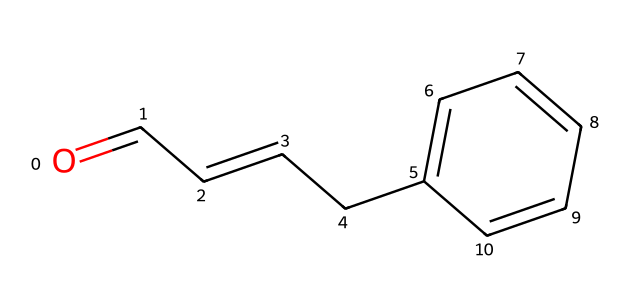What is the carbon count in cinnamaldehyde? By examining the SMILES representation, we identify that there are 9 carbon atoms in the structure; each "C" represents a carbon atom, and we count a total of 9, including those in the aromatic ring and the chain.
Answer: 9 How many hydrogen atoms are bonded to the carbon atoms? In the SMILES representation, every carbon typically bonds with enough hydrogen atoms to satisfy a total of four bonds. Counting the explicitly shown hydrogens in the chemical structure, there are 8 hydrogen atoms connected to the carbon skeleton.
Answer: 8 What type of functional group is present in cinnamaldehyde? The structure includes a carbonyl group (C=O) located at the terminal carbon, characteristic of aldehydes, indicating that it's an aldehyde.
Answer: aldehyde What is the molecular formula of cinnamaldehyde? By interpreting the carbon (C), hydrogen (H), and oxygen (O) counts from the SMILES, we derive the molecular formula: C9H8O, accounting for all the present atoms in the compound.
Answer: C9H8O What type of isomerism is exhibited by cinnamaldehyde? The structure has a double bond between carbon atoms in the chain and includes groups that can lead to geometric isomerism; thus, the isomerism displayed is stereoisomerism due to the presence of the C=C bond.
Answer: stereoisomerism 